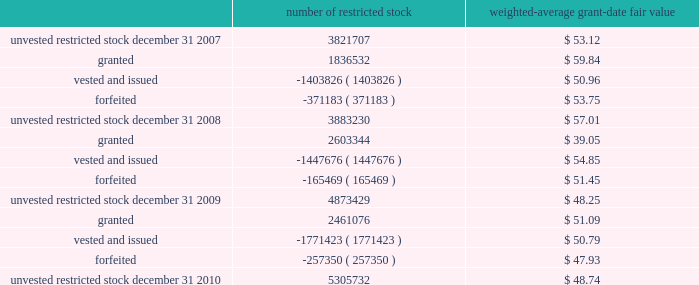N o t e s t o t h e c o n s o l i d a t e d f i n a n c i a l s t a t e m e n t s 2013 ( continued ) ace limited and subsidiaries the weighted-average remaining contractual term was 5.7 years for the stock options outstanding and 4.3 years for the stock options exercisable at december 31 , 2010 .
The total intrinsic value was $ 184 million for stock options outstanding and $ 124 million for stock options exercisable at december 31 , 2010 .
The weighted-average fair value for the stock options granted for the years ended december 31 , 2010 , 2009 , and 2008 , was $ 12.09 , $ 12.95 , and $ 17.60 , respectively .
The total intrinsic value for stock options exercised during the years ended december 31 , 2010 , 2009 , and 2008 , was $ 22 million , $ 12 mil- lion , and $ 54 million , respectively .
The amount of cash received during the year ended december 31 , 2010 , from the exercise of stock options was $ 53 million .
Restricted stock and restricted stock units the company 2019s 2004 ltip provides for grants of restricted stock and restricted stock units with a 4-year vesting period , based on a graded vesting schedule .
The company also grants restricted stock awards to non-management directors which vest at the following year 2019s annual general meeting .
The restricted stock is granted at market close price on the date of grant .
Each restricted stock unit represents the company 2019s obligation to deliver to the holder one common share upon vesting .
Included in the company 2019s share-based compensation expense for the year ended december 31 , 2010 , is a portion of the cost related to the unvested restricted stock granted in the years 2006 2013 2010 .
The table presents a roll-forward of the company 2019s restricted stock for the years ended december 31 , 2010 , 2009 , and 2008 .
Included in the roll-forward below are 36248 and 38154 restricted stock awards that were granted to non-management directors during 2010 and 2009 , respectively .
Number of restricted stock weighted-average grant-date fair .
During 2010 , the company awarded 326091 restricted stock units to officers of the company and its subsidiaries with a weighted-average grant date fair value of $ 50.36 .
During 2009 , 333104 restricted stock units , with a weighted-average grant date fair value of $ 38.75 , were awarded to officers of the company and its subsidiaries .
During 2008 , 223588 restricted stock units , with a weighted-average grant date fair value of $ 59.93 , were awarded to officers of the company and its subsidiaries .
At december 31 , 2010 , the number of unvested restricted stock units was 636758 .
Prior to 2009 , the company granted restricted stock units with a 1-year vesting period to non-management directors .
Delivery of common shares on account of these restricted stock units to non-management directors is deferred until six months after the date of the non-management directors 2019 termination from the board .
During 2008 , 40362 restricted stock units were awarded to non-management directors .
At december 31 , 2010 , the number of deferred restricted stock units was 230451 .
The espp gives participating employees the right to purchase common shares through payroll deductions during consecutive 201csubscription periods 201d at a purchase price of 85 percent of the fair value of a common share on the exercise date .
Annual purchases by participants are limited to the number of whole shares that can be purchased by an amount equal to ten percent .
What is the net change in the number of unvested restricted stock in 2010? 
Computations: (5305732 - 4873429)
Answer: 432303.0. 